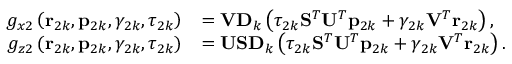<formula> <loc_0><loc_0><loc_500><loc_500>\begin{array} { r l } { g _ { x 2 } \left ( r _ { 2 k } , p _ { 2 k } , \gamma _ { 2 k } , \tau _ { 2 k } \right ) } & { = V D _ { k } \left ( \tau _ { 2 k } S ^ { T } U ^ { T } p _ { 2 k } + \gamma _ { 2 k } V ^ { T } r _ { 2 k } \right ) , } \\ { g _ { z 2 } \left ( r _ { 2 k } , p _ { 2 k } , \gamma _ { 2 k } , \tau _ { 2 k } \right ) } & { = U S D _ { k } \left ( \tau _ { 2 k } S ^ { T } U ^ { T } p _ { 2 k } + \gamma _ { 2 k } V ^ { T } r _ { 2 k } \right ) . } \end{array}</formula> 